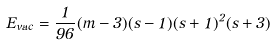Convert formula to latex. <formula><loc_0><loc_0><loc_500><loc_500>E _ { v a c } = \frac { 1 } { 9 6 } ( m - 3 ) ( s - 1 ) ( s + 1 ) ^ { 2 } ( s + 3 )</formula> 